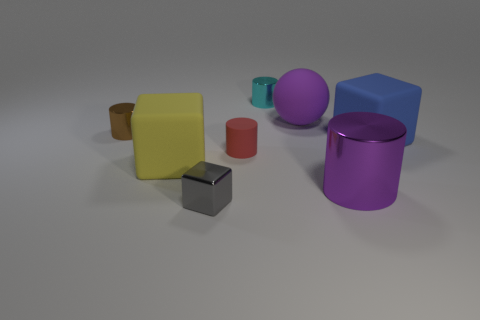Add 1 metal objects. How many objects exist? 9 Subtract all blocks. How many objects are left? 5 Subtract 0 yellow balls. How many objects are left? 8 Subtract all red rubber things. Subtract all large yellow things. How many objects are left? 6 Add 7 tiny rubber objects. How many tiny rubber objects are left? 8 Add 5 purple rubber balls. How many purple rubber balls exist? 6 